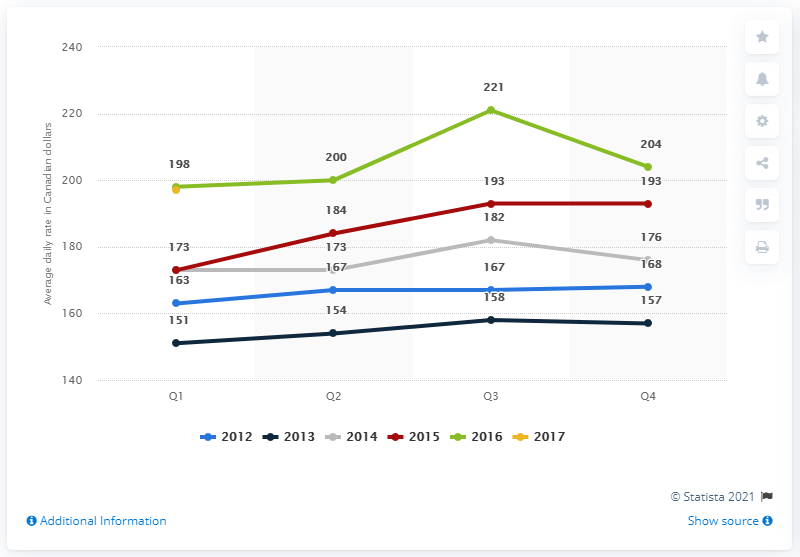Specify some key components in this picture. In the first quarter of 2017, the average daily rate of hotels in Toronto, Canada was $197. The difference between the maximum average daily rate in the first quarter of a hotel in Toronto from 2012 to 2017 and the minimum average daily rate in the fourth quarter of the same period is 41%. 